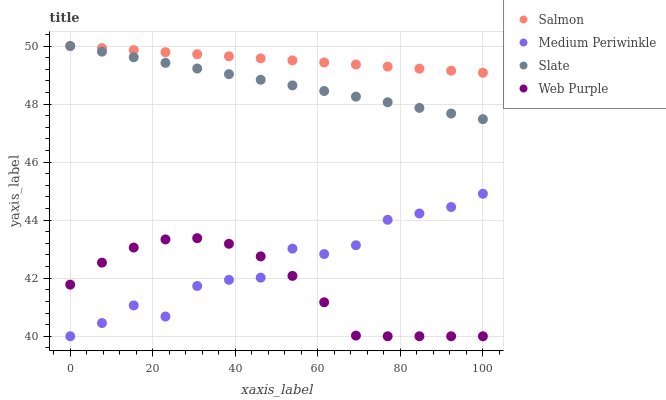Does Web Purple have the minimum area under the curve?
Answer yes or no. Yes. Does Salmon have the maximum area under the curve?
Answer yes or no. Yes. Does Slate have the minimum area under the curve?
Answer yes or no. No. Does Slate have the maximum area under the curve?
Answer yes or no. No. Is Salmon the smoothest?
Answer yes or no. Yes. Is Medium Periwinkle the roughest?
Answer yes or no. Yes. Is Slate the smoothest?
Answer yes or no. No. Is Slate the roughest?
Answer yes or no. No. Does Medium Periwinkle have the lowest value?
Answer yes or no. Yes. Does Slate have the lowest value?
Answer yes or no. No. Does Salmon have the highest value?
Answer yes or no. Yes. Does Web Purple have the highest value?
Answer yes or no. No. Is Web Purple less than Slate?
Answer yes or no. Yes. Is Salmon greater than Medium Periwinkle?
Answer yes or no. Yes. Does Web Purple intersect Medium Periwinkle?
Answer yes or no. Yes. Is Web Purple less than Medium Periwinkle?
Answer yes or no. No. Is Web Purple greater than Medium Periwinkle?
Answer yes or no. No. Does Web Purple intersect Slate?
Answer yes or no. No. 